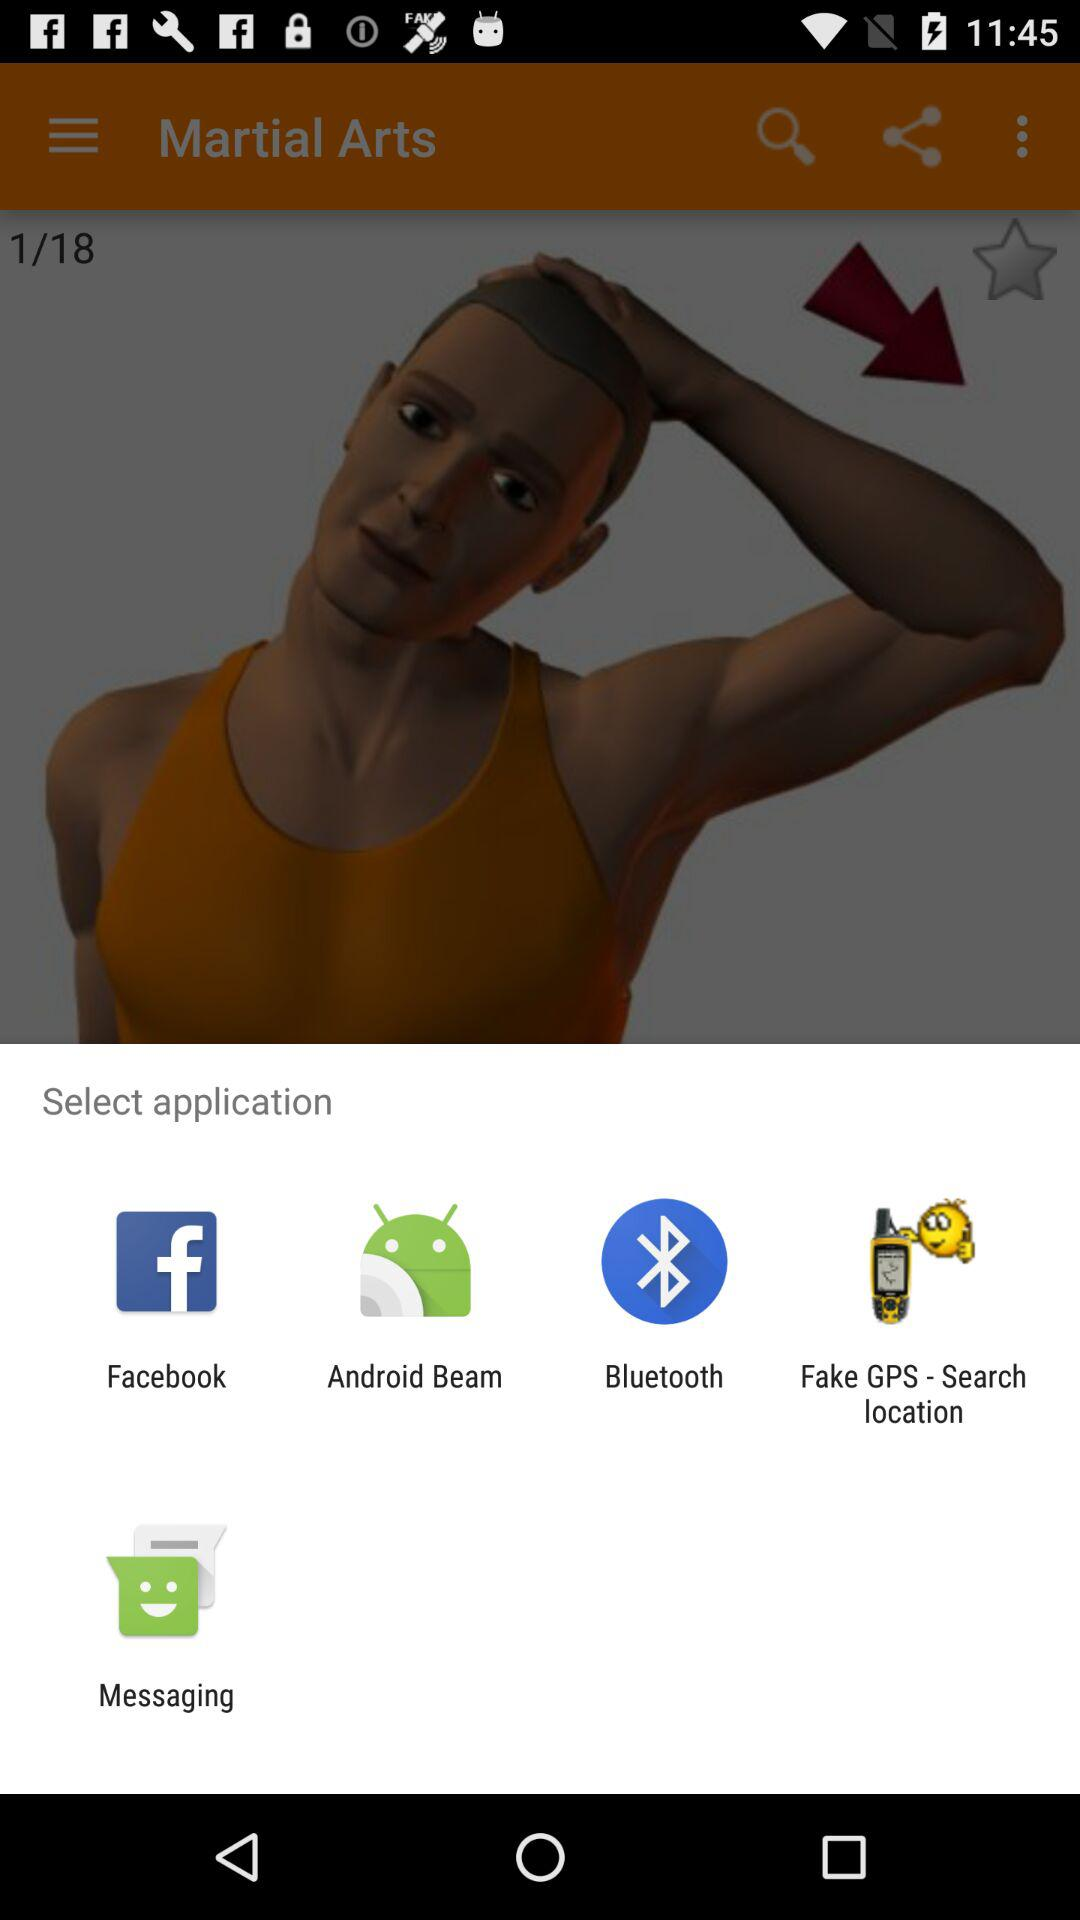What are applications given to select? The applications given to select are "Facebook", "Android Beam", "Bluetooth", "Fake GPS - Search location" and "Messaging". 